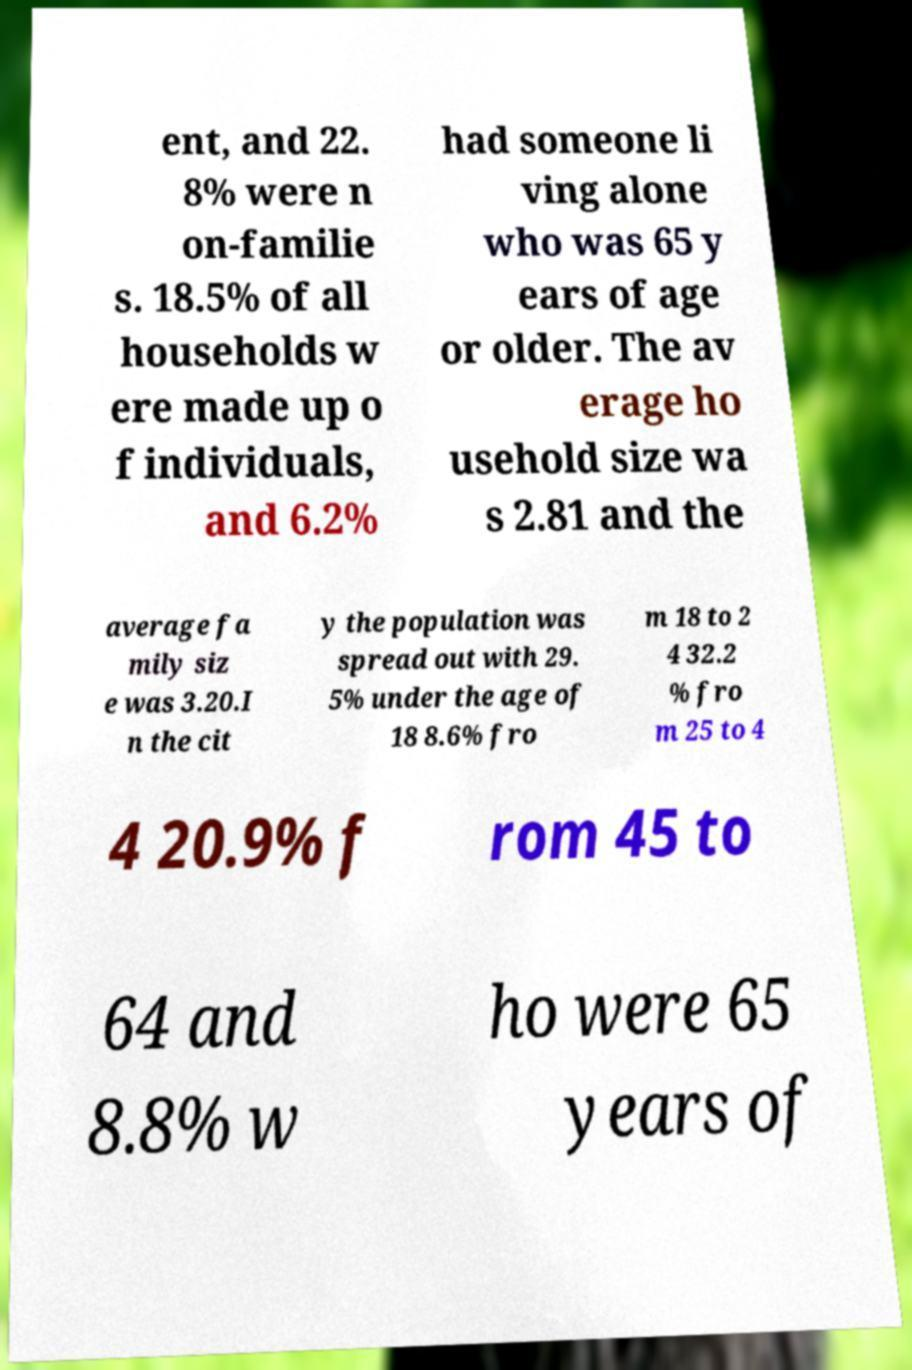I need the written content from this picture converted into text. Can you do that? ent, and 22. 8% were n on-familie s. 18.5% of all households w ere made up o f individuals, and 6.2% had someone li ving alone who was 65 y ears of age or older. The av erage ho usehold size wa s 2.81 and the average fa mily siz e was 3.20.I n the cit y the population was spread out with 29. 5% under the age of 18 8.6% fro m 18 to 2 4 32.2 % fro m 25 to 4 4 20.9% f rom 45 to 64 and 8.8% w ho were 65 years of 